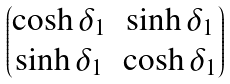Convert formula to latex. <formula><loc_0><loc_0><loc_500><loc_500>\begin{pmatrix} \cosh \delta _ { 1 } & \sinh \delta _ { 1 } \\ \sinh \delta _ { 1 } & \cosh \delta _ { 1 } \end{pmatrix}</formula> 